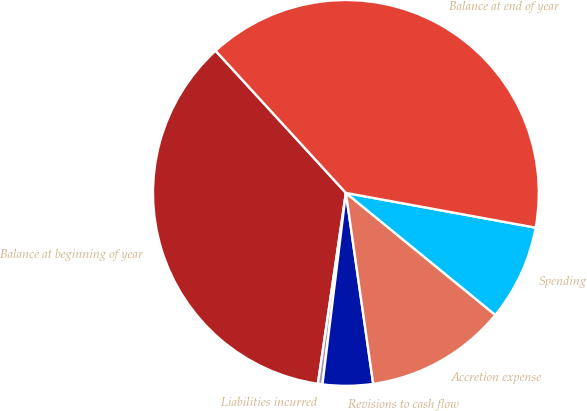Convert chart to OTSL. <chart><loc_0><loc_0><loc_500><loc_500><pie_chart><fcel>Balance at beginning of year<fcel>Liabilities incurred<fcel>Revisions to cash flow<fcel>Accretion expense<fcel>Spending<fcel>Balance at end of year<nl><fcel>35.87%<fcel>0.38%<fcel>4.2%<fcel>11.84%<fcel>8.02%<fcel>39.69%<nl></chart> 